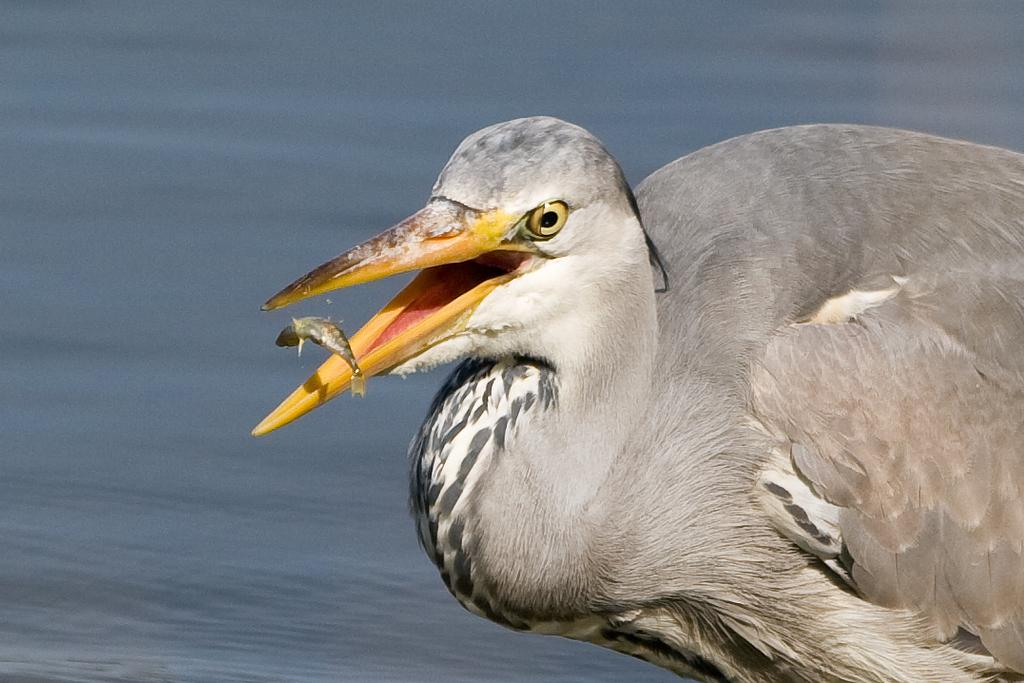What is the main subject in the foreground of the image? There is a bird in the foreground of the image. What other animal can be seen in the image? There is a fish in the image. What type of environment is depicted in the background of the image? There is water visible in the background of the image. What message of peace is conveyed by the picture? There is no message of peace conveyed by the picture, as it simply depicts a bird and a fish in a watery environment. 